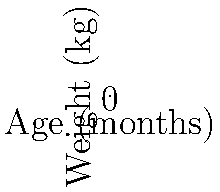As a pediatric resident, you are analyzing growth charts of infants who received different nutritional interventions. The graph shows the weight gain of two groups of infants over the first 12 months of life. Which intervention resulted in a higher weight gain, and what is the approximate difference in weight between the two groups at 12 months of age? To answer this question, we need to follow these steps:

1. Identify the two interventions on the graph:
   - Blue line represents Intervention A
   - Red line represents Intervention B

2. Compare the growth trajectories:
   - Both groups start at the same weight (approximately 3.5 kg) at birth
   - The blue line (Intervention A) consistently shows higher weights at each time point

3. Determine which intervention resulted in higher weight gain:
   - Since the blue line (Intervention A) is above the red line (Intervention B) throughout the graph, Intervention A resulted in higher weight gain

4. Calculate the approximate difference in weight at 12 months:
   - At 12 months, Intervention A (blue line) shows a weight of approximately 9.3 kg
   - At 12 months, Intervention B (red line) shows a weight of approximately 8.5 kg
   - Difference: 9.3 kg - 8.5 kg = 0.8 kg

Therefore, Intervention A resulted in higher weight gain, and the approximate difference in weight between the two groups at 12 months of age is 0.8 kg.
Answer: Intervention A; 0.8 kg 